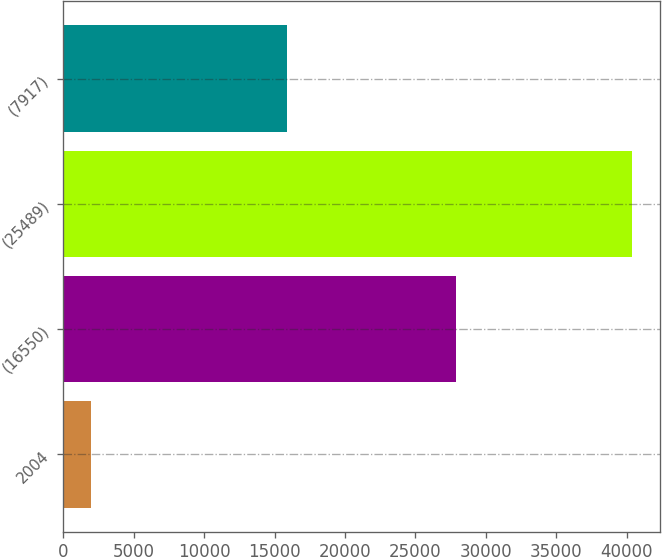Convert chart to OTSL. <chart><loc_0><loc_0><loc_500><loc_500><bar_chart><fcel>2004<fcel>(16550)<fcel>(25489)<fcel>(7917)<nl><fcel>2003<fcel>27868<fcel>40364<fcel>15906<nl></chart> 